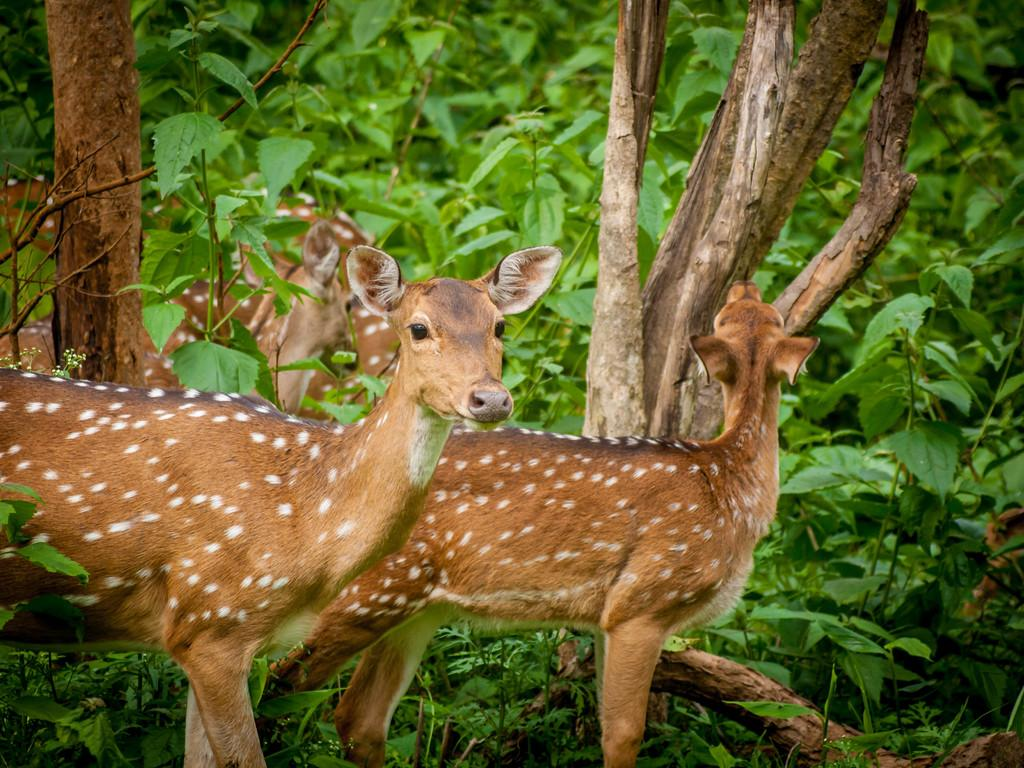What animals can be seen in the image? There are two deer in the image. What can be seen in the background of the image? There are many trees in the background of the image. How many deer are present in the image? There is a herd of deer in the image. What statement is being made by the eyes of the deer in the image? There is no statement being made by the eyes of the deer in the image, as eyes do not have the ability to make statements. 